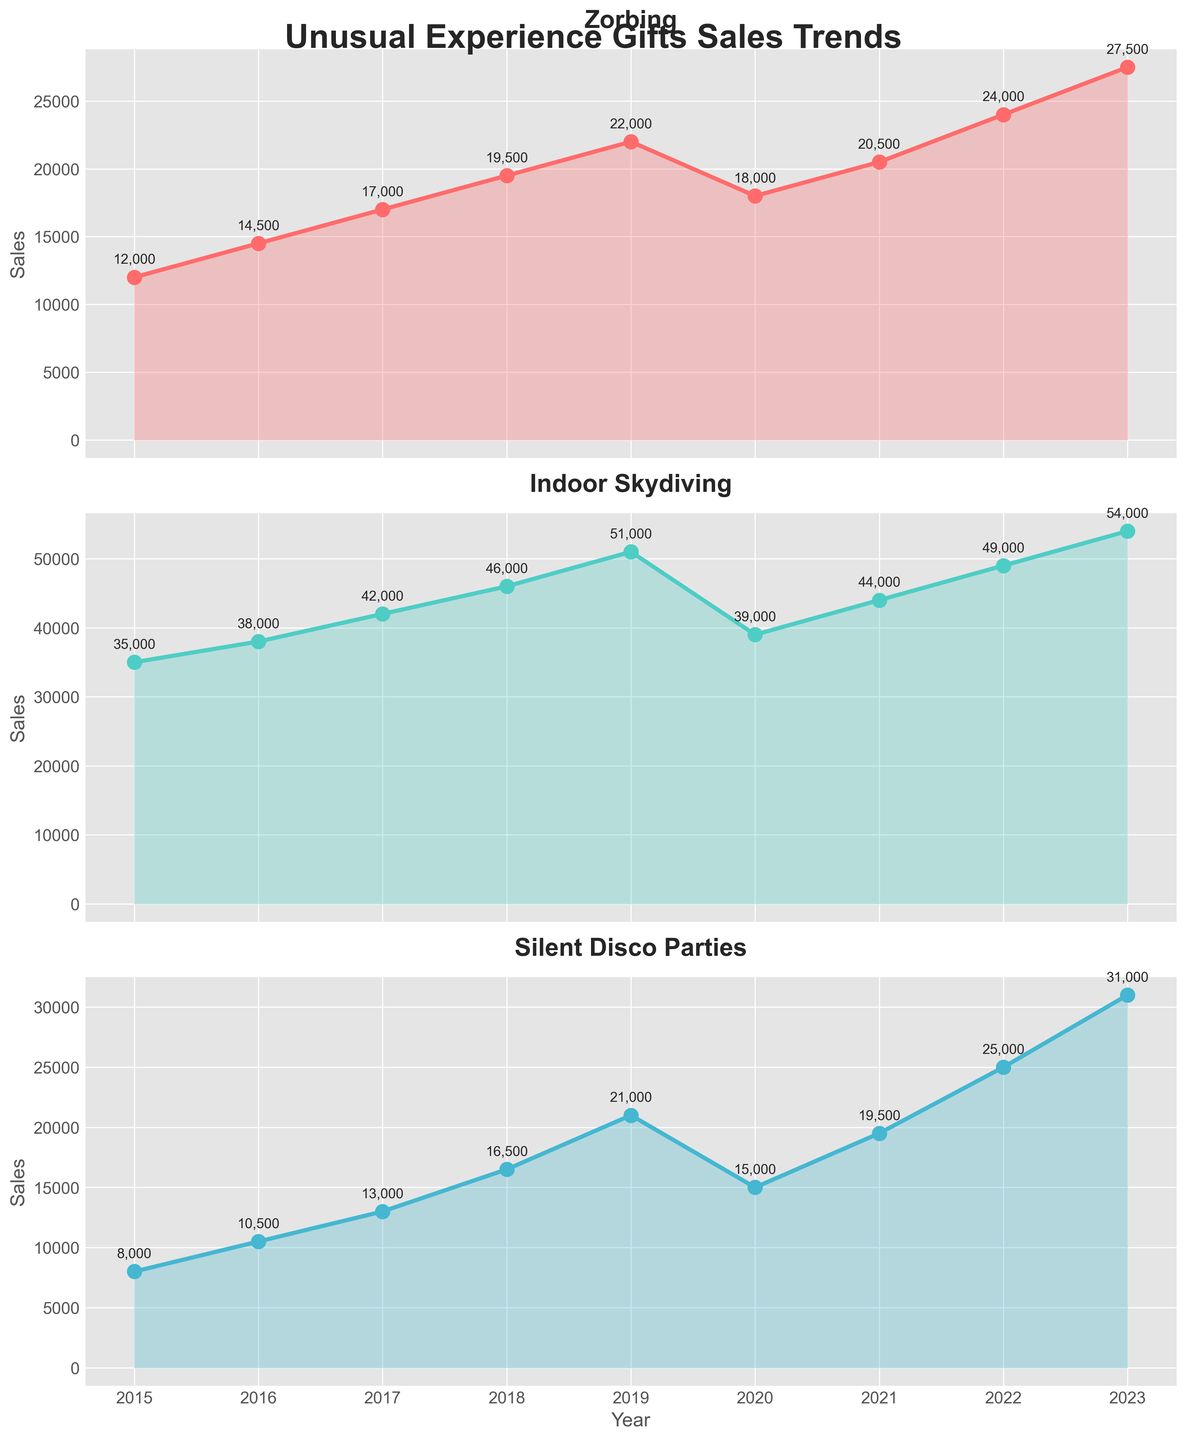Compare the sales trend of Zorbing and Indoor Skydiving from 2015 to 2019. Which activity saw a more significant increase during this period? To compare the trends, calculate the differences in sales for both activities from 2015 to 2019. For Zorbing, the sales in 2015 were 12,000 and 22,000 in 2019, an increase of 10,000. For Indoor Skydiving, the sales were 35,000 in 2015 and 51,000 in 2019, an increase of 16,000. Thus, Indoor Skydiving saw a more significant increase.
Answer: Indoor Skydiving What is the percentage decrease in sales for Zorbing from 2019 to 2020? First, compute the difference in sales for Zorbing from 2019 to 2020: 22,000 - 18,000 = 4,000. Next, calculate the percentage decrease with the formula (decrease/original value) * 100 = (4,000/22,000) * 100 ≈ 18.18%.
Answer: 18.18% Which year had the lowest sales for Silent Disco Parties, and what were the sales? By examining the data for Silent Disco Parties over the years, the lowest sales occurred in 2015 with 8,000 sales.
Answer: 2015, 8,000 What was the combined total sales for all three activities in 2021? To find the total sales in 2021, sum the sales of Zorbing, Indoor Skydiving, and Silent Disco Parties: 20,500 + 44,000 + 19,500 = 84,000.
Answer: 84,000 Between 2021 and 2022, which activity showed the highest increase in sales and by how much? Calculate the sales increase for each activity from 2021 to 2022. Zorbing: 24,000 - 20,500 = 3,500. Indoor Skydiving: 49,000 - 44,000 = 5,000. Silent Disco Parties: 25,000 - 19,500 = 5,500. Silent Disco Parties showed the highest increase by 5,500.
Answer: Silent Disco Parties, 5,500 What is the average sales for Zorbing from 2015 to 2017? To find the average, sum up the sales of Zorbing for the years 2015, 2016, and 2017 and then divide by 3: (12,000 + 14,500 + 17,000) / 3 = 43,500 / 3 ≈ 14,500.
Answer: 14,500 Compare the sales of Silent Disco Parties in 2020 to its sales in 2023. Does 2023 show more than a 100% increase from 2020? First, compute the sales difference: 31,000 - 15,000 = 16,000. Then, calculate the percentage increase: (16,000 / 15,000) * 100 = 106.67%. Yes, 2023 shows more than a 100% increase from 2020.
Answer: Yes, 106.67% Which activity had a steady increase in sales every year from 2015 to 2019? By examining the yearly sales data for all three activities, Indoor Skydiving had a steady increase in sales every year from 2015 (35,000) to 2019 (51,000).
Answer: Indoor Skydiving How much more were the sales of Indoor Skydiving than Zorbing in 2023? To find the difference in sales between Indoor Skydiving and Zorbing in 2023, subtract Zorbing sales from Indoor Skydiving sales: 54,000 - 27,500 = 26,500.
Answer: 26,500 